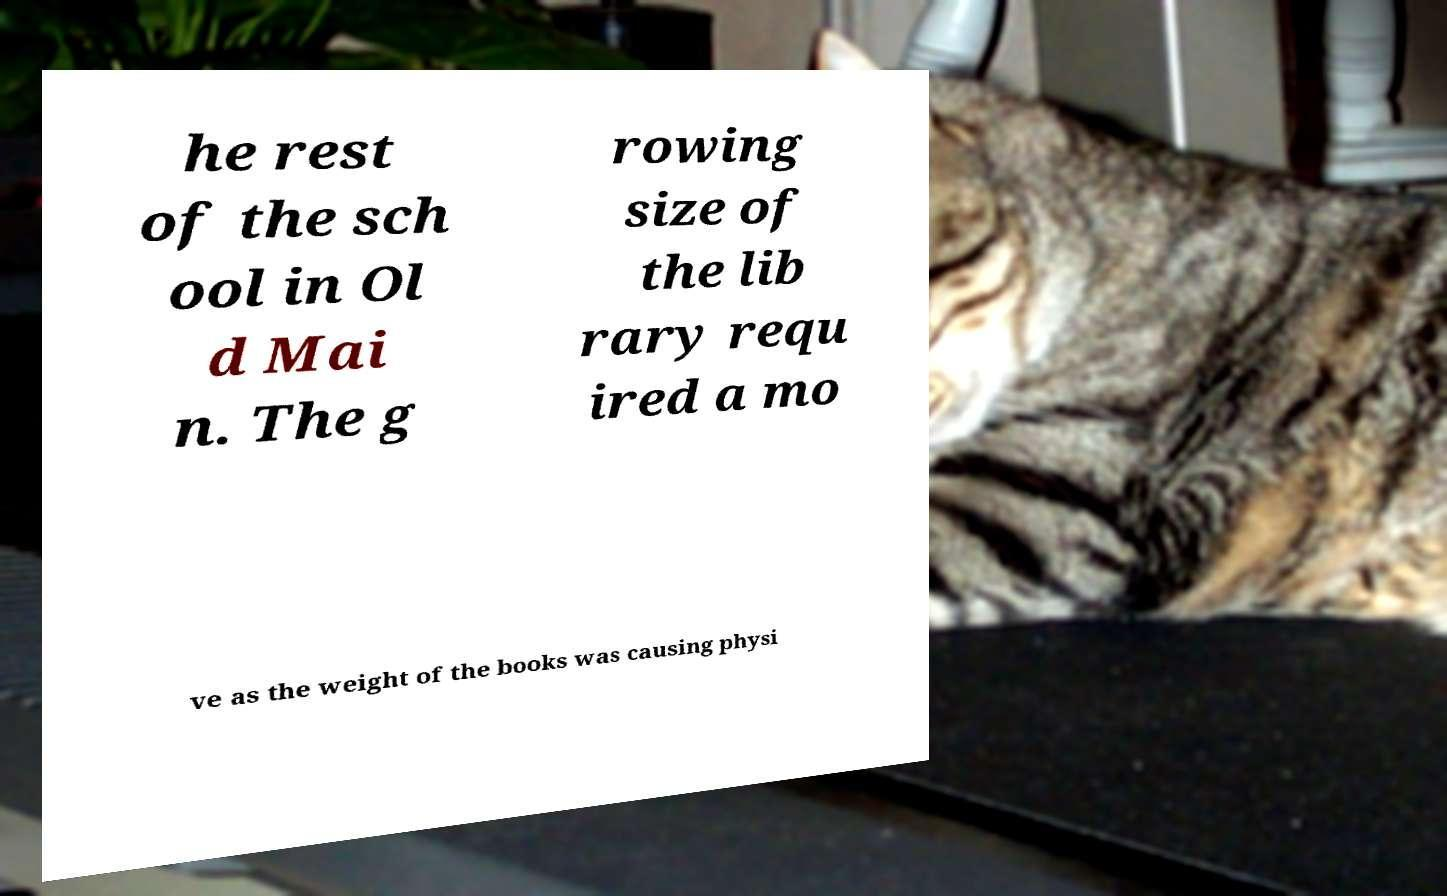Could you assist in decoding the text presented in this image and type it out clearly? he rest of the sch ool in Ol d Mai n. The g rowing size of the lib rary requ ired a mo ve as the weight of the books was causing physi 